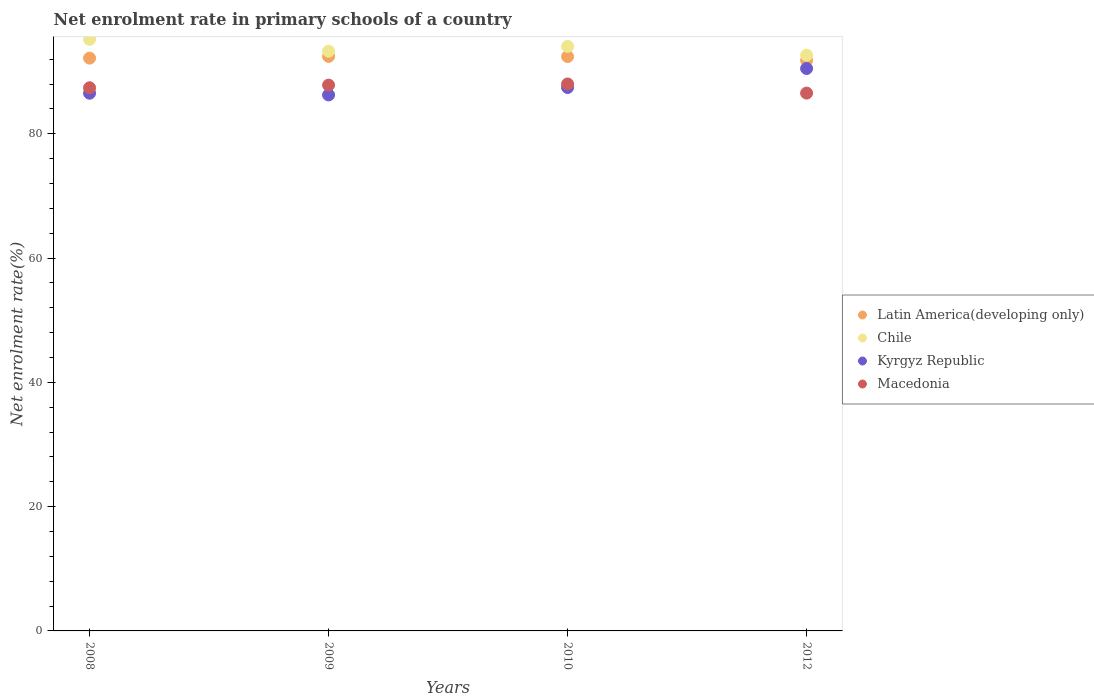How many different coloured dotlines are there?
Your answer should be compact. 4. What is the net enrolment rate in primary schools in Chile in 2010?
Your response must be concise. 94.06. Across all years, what is the maximum net enrolment rate in primary schools in Macedonia?
Your answer should be very brief. 88.02. Across all years, what is the minimum net enrolment rate in primary schools in Kyrgyz Republic?
Your answer should be compact. 86.25. In which year was the net enrolment rate in primary schools in Macedonia maximum?
Your response must be concise. 2010. What is the total net enrolment rate in primary schools in Kyrgyz Republic in the graph?
Ensure brevity in your answer.  350.74. What is the difference between the net enrolment rate in primary schools in Kyrgyz Republic in 2010 and that in 2012?
Offer a very short reply. -3.06. What is the difference between the net enrolment rate in primary schools in Chile in 2009 and the net enrolment rate in primary schools in Latin America(developing only) in 2012?
Give a very brief answer. 1.47. What is the average net enrolment rate in primary schools in Latin America(developing only) per year?
Your response must be concise. 92.22. In the year 2009, what is the difference between the net enrolment rate in primary schools in Macedonia and net enrolment rate in primary schools in Kyrgyz Republic?
Keep it short and to the point. 1.58. In how many years, is the net enrolment rate in primary schools in Kyrgyz Republic greater than 16 %?
Your answer should be compact. 4. What is the ratio of the net enrolment rate in primary schools in Macedonia in 2008 to that in 2012?
Provide a short and direct response. 1.01. Is the difference between the net enrolment rate in primary schools in Macedonia in 2009 and 2010 greater than the difference between the net enrolment rate in primary schools in Kyrgyz Republic in 2009 and 2010?
Your response must be concise. Yes. What is the difference between the highest and the second highest net enrolment rate in primary schools in Kyrgyz Republic?
Provide a succinct answer. 3.06. What is the difference between the highest and the lowest net enrolment rate in primary schools in Kyrgyz Republic?
Your answer should be compact. 4.25. Is it the case that in every year, the sum of the net enrolment rate in primary schools in Kyrgyz Republic and net enrolment rate in primary schools in Chile  is greater than the net enrolment rate in primary schools in Macedonia?
Ensure brevity in your answer.  Yes. Does the net enrolment rate in primary schools in Latin America(developing only) monotonically increase over the years?
Offer a very short reply. No. Is the net enrolment rate in primary schools in Macedonia strictly less than the net enrolment rate in primary schools in Kyrgyz Republic over the years?
Make the answer very short. No. How many dotlines are there?
Provide a succinct answer. 4. How many years are there in the graph?
Provide a short and direct response. 4. Does the graph contain any zero values?
Provide a short and direct response. No. How many legend labels are there?
Your response must be concise. 4. What is the title of the graph?
Make the answer very short. Net enrolment rate in primary schools of a country. Does "Ireland" appear as one of the legend labels in the graph?
Your response must be concise. No. What is the label or title of the X-axis?
Keep it short and to the point. Years. What is the label or title of the Y-axis?
Your answer should be very brief. Net enrolment rate(%). What is the Net enrolment rate(%) in Latin America(developing only) in 2008?
Keep it short and to the point. 92.18. What is the Net enrolment rate(%) in Chile in 2008?
Keep it short and to the point. 95.2. What is the Net enrolment rate(%) in Kyrgyz Republic in 2008?
Provide a short and direct response. 86.53. What is the Net enrolment rate(%) in Macedonia in 2008?
Provide a short and direct response. 87.41. What is the Net enrolment rate(%) in Latin America(developing only) in 2009?
Provide a succinct answer. 92.46. What is the Net enrolment rate(%) in Chile in 2009?
Offer a very short reply. 93.28. What is the Net enrolment rate(%) in Kyrgyz Republic in 2009?
Ensure brevity in your answer.  86.25. What is the Net enrolment rate(%) of Macedonia in 2009?
Your answer should be compact. 87.84. What is the Net enrolment rate(%) in Latin America(developing only) in 2010?
Offer a very short reply. 92.43. What is the Net enrolment rate(%) in Chile in 2010?
Ensure brevity in your answer.  94.06. What is the Net enrolment rate(%) of Kyrgyz Republic in 2010?
Your response must be concise. 87.45. What is the Net enrolment rate(%) in Macedonia in 2010?
Offer a very short reply. 88.02. What is the Net enrolment rate(%) of Latin America(developing only) in 2012?
Your answer should be very brief. 91.81. What is the Net enrolment rate(%) of Chile in 2012?
Your answer should be compact. 92.65. What is the Net enrolment rate(%) of Kyrgyz Republic in 2012?
Give a very brief answer. 90.51. What is the Net enrolment rate(%) of Macedonia in 2012?
Provide a short and direct response. 86.55. Across all years, what is the maximum Net enrolment rate(%) in Latin America(developing only)?
Your answer should be compact. 92.46. Across all years, what is the maximum Net enrolment rate(%) in Chile?
Give a very brief answer. 95.2. Across all years, what is the maximum Net enrolment rate(%) of Kyrgyz Republic?
Make the answer very short. 90.51. Across all years, what is the maximum Net enrolment rate(%) of Macedonia?
Your answer should be compact. 88.02. Across all years, what is the minimum Net enrolment rate(%) in Latin America(developing only)?
Provide a succinct answer. 91.81. Across all years, what is the minimum Net enrolment rate(%) in Chile?
Ensure brevity in your answer.  92.65. Across all years, what is the minimum Net enrolment rate(%) in Kyrgyz Republic?
Your answer should be very brief. 86.25. Across all years, what is the minimum Net enrolment rate(%) in Macedonia?
Make the answer very short. 86.55. What is the total Net enrolment rate(%) in Latin America(developing only) in the graph?
Provide a short and direct response. 368.88. What is the total Net enrolment rate(%) in Chile in the graph?
Make the answer very short. 375.2. What is the total Net enrolment rate(%) of Kyrgyz Republic in the graph?
Keep it short and to the point. 350.74. What is the total Net enrolment rate(%) in Macedonia in the graph?
Make the answer very short. 349.81. What is the difference between the Net enrolment rate(%) in Latin America(developing only) in 2008 and that in 2009?
Your response must be concise. -0.28. What is the difference between the Net enrolment rate(%) in Chile in 2008 and that in 2009?
Give a very brief answer. 1.92. What is the difference between the Net enrolment rate(%) of Kyrgyz Republic in 2008 and that in 2009?
Your answer should be very brief. 0.27. What is the difference between the Net enrolment rate(%) in Macedonia in 2008 and that in 2009?
Keep it short and to the point. -0.43. What is the difference between the Net enrolment rate(%) in Latin America(developing only) in 2008 and that in 2010?
Ensure brevity in your answer.  -0.25. What is the difference between the Net enrolment rate(%) of Chile in 2008 and that in 2010?
Make the answer very short. 1.14. What is the difference between the Net enrolment rate(%) in Kyrgyz Republic in 2008 and that in 2010?
Ensure brevity in your answer.  -0.92. What is the difference between the Net enrolment rate(%) in Macedonia in 2008 and that in 2010?
Give a very brief answer. -0.61. What is the difference between the Net enrolment rate(%) of Latin America(developing only) in 2008 and that in 2012?
Your response must be concise. 0.36. What is the difference between the Net enrolment rate(%) of Chile in 2008 and that in 2012?
Make the answer very short. 2.54. What is the difference between the Net enrolment rate(%) of Kyrgyz Republic in 2008 and that in 2012?
Offer a terse response. -3.98. What is the difference between the Net enrolment rate(%) of Macedonia in 2008 and that in 2012?
Ensure brevity in your answer.  0.86. What is the difference between the Net enrolment rate(%) in Latin America(developing only) in 2009 and that in 2010?
Keep it short and to the point. 0.03. What is the difference between the Net enrolment rate(%) in Chile in 2009 and that in 2010?
Ensure brevity in your answer.  -0.78. What is the difference between the Net enrolment rate(%) of Kyrgyz Republic in 2009 and that in 2010?
Provide a short and direct response. -1.19. What is the difference between the Net enrolment rate(%) in Macedonia in 2009 and that in 2010?
Ensure brevity in your answer.  -0.18. What is the difference between the Net enrolment rate(%) in Latin America(developing only) in 2009 and that in 2012?
Provide a short and direct response. 0.64. What is the difference between the Net enrolment rate(%) of Chile in 2009 and that in 2012?
Your answer should be very brief. 0.63. What is the difference between the Net enrolment rate(%) in Kyrgyz Republic in 2009 and that in 2012?
Offer a terse response. -4.25. What is the difference between the Net enrolment rate(%) of Macedonia in 2009 and that in 2012?
Offer a terse response. 1.29. What is the difference between the Net enrolment rate(%) of Latin America(developing only) in 2010 and that in 2012?
Keep it short and to the point. 0.62. What is the difference between the Net enrolment rate(%) of Chile in 2010 and that in 2012?
Make the answer very short. 1.41. What is the difference between the Net enrolment rate(%) in Kyrgyz Republic in 2010 and that in 2012?
Your response must be concise. -3.06. What is the difference between the Net enrolment rate(%) of Macedonia in 2010 and that in 2012?
Your answer should be very brief. 1.47. What is the difference between the Net enrolment rate(%) in Latin America(developing only) in 2008 and the Net enrolment rate(%) in Chile in 2009?
Your answer should be compact. -1.11. What is the difference between the Net enrolment rate(%) in Latin America(developing only) in 2008 and the Net enrolment rate(%) in Kyrgyz Republic in 2009?
Your answer should be compact. 5.92. What is the difference between the Net enrolment rate(%) of Latin America(developing only) in 2008 and the Net enrolment rate(%) of Macedonia in 2009?
Provide a succinct answer. 4.34. What is the difference between the Net enrolment rate(%) in Chile in 2008 and the Net enrolment rate(%) in Kyrgyz Republic in 2009?
Provide a succinct answer. 8.94. What is the difference between the Net enrolment rate(%) in Chile in 2008 and the Net enrolment rate(%) in Macedonia in 2009?
Make the answer very short. 7.36. What is the difference between the Net enrolment rate(%) in Kyrgyz Republic in 2008 and the Net enrolment rate(%) in Macedonia in 2009?
Keep it short and to the point. -1.31. What is the difference between the Net enrolment rate(%) in Latin America(developing only) in 2008 and the Net enrolment rate(%) in Chile in 2010?
Make the answer very short. -1.88. What is the difference between the Net enrolment rate(%) of Latin America(developing only) in 2008 and the Net enrolment rate(%) of Kyrgyz Republic in 2010?
Provide a succinct answer. 4.73. What is the difference between the Net enrolment rate(%) of Latin America(developing only) in 2008 and the Net enrolment rate(%) of Macedonia in 2010?
Offer a terse response. 4.16. What is the difference between the Net enrolment rate(%) of Chile in 2008 and the Net enrolment rate(%) of Kyrgyz Republic in 2010?
Provide a succinct answer. 7.75. What is the difference between the Net enrolment rate(%) of Chile in 2008 and the Net enrolment rate(%) of Macedonia in 2010?
Offer a terse response. 7.18. What is the difference between the Net enrolment rate(%) in Kyrgyz Republic in 2008 and the Net enrolment rate(%) in Macedonia in 2010?
Offer a very short reply. -1.49. What is the difference between the Net enrolment rate(%) in Latin America(developing only) in 2008 and the Net enrolment rate(%) in Chile in 2012?
Ensure brevity in your answer.  -0.48. What is the difference between the Net enrolment rate(%) in Latin America(developing only) in 2008 and the Net enrolment rate(%) in Kyrgyz Republic in 2012?
Offer a terse response. 1.67. What is the difference between the Net enrolment rate(%) in Latin America(developing only) in 2008 and the Net enrolment rate(%) in Macedonia in 2012?
Offer a very short reply. 5.63. What is the difference between the Net enrolment rate(%) of Chile in 2008 and the Net enrolment rate(%) of Kyrgyz Republic in 2012?
Offer a terse response. 4.69. What is the difference between the Net enrolment rate(%) in Chile in 2008 and the Net enrolment rate(%) in Macedonia in 2012?
Make the answer very short. 8.65. What is the difference between the Net enrolment rate(%) of Kyrgyz Republic in 2008 and the Net enrolment rate(%) of Macedonia in 2012?
Provide a succinct answer. -0.02. What is the difference between the Net enrolment rate(%) in Latin America(developing only) in 2009 and the Net enrolment rate(%) in Chile in 2010?
Offer a terse response. -1.61. What is the difference between the Net enrolment rate(%) in Latin America(developing only) in 2009 and the Net enrolment rate(%) in Kyrgyz Republic in 2010?
Your response must be concise. 5.01. What is the difference between the Net enrolment rate(%) in Latin America(developing only) in 2009 and the Net enrolment rate(%) in Macedonia in 2010?
Give a very brief answer. 4.44. What is the difference between the Net enrolment rate(%) in Chile in 2009 and the Net enrolment rate(%) in Kyrgyz Republic in 2010?
Your answer should be compact. 5.84. What is the difference between the Net enrolment rate(%) in Chile in 2009 and the Net enrolment rate(%) in Macedonia in 2010?
Ensure brevity in your answer.  5.26. What is the difference between the Net enrolment rate(%) of Kyrgyz Republic in 2009 and the Net enrolment rate(%) of Macedonia in 2010?
Offer a very short reply. -1.77. What is the difference between the Net enrolment rate(%) in Latin America(developing only) in 2009 and the Net enrolment rate(%) in Chile in 2012?
Offer a very short reply. -0.2. What is the difference between the Net enrolment rate(%) in Latin America(developing only) in 2009 and the Net enrolment rate(%) in Kyrgyz Republic in 2012?
Make the answer very short. 1.95. What is the difference between the Net enrolment rate(%) of Latin America(developing only) in 2009 and the Net enrolment rate(%) of Macedonia in 2012?
Your response must be concise. 5.91. What is the difference between the Net enrolment rate(%) of Chile in 2009 and the Net enrolment rate(%) of Kyrgyz Republic in 2012?
Your answer should be compact. 2.78. What is the difference between the Net enrolment rate(%) of Chile in 2009 and the Net enrolment rate(%) of Macedonia in 2012?
Offer a terse response. 6.73. What is the difference between the Net enrolment rate(%) of Kyrgyz Republic in 2009 and the Net enrolment rate(%) of Macedonia in 2012?
Ensure brevity in your answer.  -0.29. What is the difference between the Net enrolment rate(%) of Latin America(developing only) in 2010 and the Net enrolment rate(%) of Chile in 2012?
Give a very brief answer. -0.22. What is the difference between the Net enrolment rate(%) of Latin America(developing only) in 2010 and the Net enrolment rate(%) of Kyrgyz Republic in 2012?
Your answer should be very brief. 1.92. What is the difference between the Net enrolment rate(%) in Latin America(developing only) in 2010 and the Net enrolment rate(%) in Macedonia in 2012?
Keep it short and to the point. 5.88. What is the difference between the Net enrolment rate(%) in Chile in 2010 and the Net enrolment rate(%) in Kyrgyz Republic in 2012?
Your answer should be very brief. 3.56. What is the difference between the Net enrolment rate(%) in Chile in 2010 and the Net enrolment rate(%) in Macedonia in 2012?
Provide a short and direct response. 7.51. What is the difference between the Net enrolment rate(%) in Kyrgyz Republic in 2010 and the Net enrolment rate(%) in Macedonia in 2012?
Offer a terse response. 0.9. What is the average Net enrolment rate(%) of Latin America(developing only) per year?
Your response must be concise. 92.22. What is the average Net enrolment rate(%) in Chile per year?
Make the answer very short. 93.8. What is the average Net enrolment rate(%) in Kyrgyz Republic per year?
Provide a short and direct response. 87.68. What is the average Net enrolment rate(%) in Macedonia per year?
Your answer should be compact. 87.45. In the year 2008, what is the difference between the Net enrolment rate(%) in Latin America(developing only) and Net enrolment rate(%) in Chile?
Give a very brief answer. -3.02. In the year 2008, what is the difference between the Net enrolment rate(%) of Latin America(developing only) and Net enrolment rate(%) of Kyrgyz Republic?
Make the answer very short. 5.65. In the year 2008, what is the difference between the Net enrolment rate(%) in Latin America(developing only) and Net enrolment rate(%) in Macedonia?
Keep it short and to the point. 4.77. In the year 2008, what is the difference between the Net enrolment rate(%) in Chile and Net enrolment rate(%) in Kyrgyz Republic?
Offer a very short reply. 8.67. In the year 2008, what is the difference between the Net enrolment rate(%) in Chile and Net enrolment rate(%) in Macedonia?
Provide a succinct answer. 7.79. In the year 2008, what is the difference between the Net enrolment rate(%) in Kyrgyz Republic and Net enrolment rate(%) in Macedonia?
Your answer should be compact. -0.88. In the year 2009, what is the difference between the Net enrolment rate(%) of Latin America(developing only) and Net enrolment rate(%) of Chile?
Offer a terse response. -0.83. In the year 2009, what is the difference between the Net enrolment rate(%) of Latin America(developing only) and Net enrolment rate(%) of Kyrgyz Republic?
Your response must be concise. 6.2. In the year 2009, what is the difference between the Net enrolment rate(%) in Latin America(developing only) and Net enrolment rate(%) in Macedonia?
Keep it short and to the point. 4.62. In the year 2009, what is the difference between the Net enrolment rate(%) of Chile and Net enrolment rate(%) of Kyrgyz Republic?
Offer a very short reply. 7.03. In the year 2009, what is the difference between the Net enrolment rate(%) in Chile and Net enrolment rate(%) in Macedonia?
Make the answer very short. 5.45. In the year 2009, what is the difference between the Net enrolment rate(%) in Kyrgyz Republic and Net enrolment rate(%) in Macedonia?
Your answer should be compact. -1.58. In the year 2010, what is the difference between the Net enrolment rate(%) of Latin America(developing only) and Net enrolment rate(%) of Chile?
Make the answer very short. -1.63. In the year 2010, what is the difference between the Net enrolment rate(%) of Latin America(developing only) and Net enrolment rate(%) of Kyrgyz Republic?
Your answer should be very brief. 4.98. In the year 2010, what is the difference between the Net enrolment rate(%) of Latin America(developing only) and Net enrolment rate(%) of Macedonia?
Your response must be concise. 4.41. In the year 2010, what is the difference between the Net enrolment rate(%) in Chile and Net enrolment rate(%) in Kyrgyz Republic?
Your answer should be compact. 6.61. In the year 2010, what is the difference between the Net enrolment rate(%) in Chile and Net enrolment rate(%) in Macedonia?
Ensure brevity in your answer.  6.04. In the year 2010, what is the difference between the Net enrolment rate(%) of Kyrgyz Republic and Net enrolment rate(%) of Macedonia?
Provide a short and direct response. -0.57. In the year 2012, what is the difference between the Net enrolment rate(%) of Latin America(developing only) and Net enrolment rate(%) of Chile?
Offer a terse response. -0.84. In the year 2012, what is the difference between the Net enrolment rate(%) in Latin America(developing only) and Net enrolment rate(%) in Kyrgyz Republic?
Offer a very short reply. 1.31. In the year 2012, what is the difference between the Net enrolment rate(%) of Latin America(developing only) and Net enrolment rate(%) of Macedonia?
Give a very brief answer. 5.27. In the year 2012, what is the difference between the Net enrolment rate(%) in Chile and Net enrolment rate(%) in Kyrgyz Republic?
Provide a short and direct response. 2.15. In the year 2012, what is the difference between the Net enrolment rate(%) of Chile and Net enrolment rate(%) of Macedonia?
Give a very brief answer. 6.11. In the year 2012, what is the difference between the Net enrolment rate(%) in Kyrgyz Republic and Net enrolment rate(%) in Macedonia?
Provide a succinct answer. 3.96. What is the ratio of the Net enrolment rate(%) in Chile in 2008 to that in 2009?
Provide a succinct answer. 1.02. What is the ratio of the Net enrolment rate(%) of Macedonia in 2008 to that in 2009?
Give a very brief answer. 1. What is the ratio of the Net enrolment rate(%) in Chile in 2008 to that in 2010?
Your response must be concise. 1.01. What is the ratio of the Net enrolment rate(%) of Kyrgyz Republic in 2008 to that in 2010?
Your answer should be compact. 0.99. What is the ratio of the Net enrolment rate(%) in Macedonia in 2008 to that in 2010?
Your answer should be very brief. 0.99. What is the ratio of the Net enrolment rate(%) in Chile in 2008 to that in 2012?
Give a very brief answer. 1.03. What is the ratio of the Net enrolment rate(%) in Kyrgyz Republic in 2008 to that in 2012?
Make the answer very short. 0.96. What is the ratio of the Net enrolment rate(%) in Macedonia in 2008 to that in 2012?
Keep it short and to the point. 1.01. What is the ratio of the Net enrolment rate(%) in Kyrgyz Republic in 2009 to that in 2010?
Give a very brief answer. 0.99. What is the ratio of the Net enrolment rate(%) of Macedonia in 2009 to that in 2010?
Provide a short and direct response. 1. What is the ratio of the Net enrolment rate(%) in Chile in 2009 to that in 2012?
Offer a terse response. 1.01. What is the ratio of the Net enrolment rate(%) in Kyrgyz Republic in 2009 to that in 2012?
Provide a succinct answer. 0.95. What is the ratio of the Net enrolment rate(%) of Macedonia in 2009 to that in 2012?
Your answer should be very brief. 1.01. What is the ratio of the Net enrolment rate(%) of Chile in 2010 to that in 2012?
Ensure brevity in your answer.  1.02. What is the ratio of the Net enrolment rate(%) in Kyrgyz Republic in 2010 to that in 2012?
Give a very brief answer. 0.97. What is the ratio of the Net enrolment rate(%) in Macedonia in 2010 to that in 2012?
Keep it short and to the point. 1.02. What is the difference between the highest and the second highest Net enrolment rate(%) of Latin America(developing only)?
Give a very brief answer. 0.03. What is the difference between the highest and the second highest Net enrolment rate(%) of Chile?
Ensure brevity in your answer.  1.14. What is the difference between the highest and the second highest Net enrolment rate(%) in Kyrgyz Republic?
Give a very brief answer. 3.06. What is the difference between the highest and the second highest Net enrolment rate(%) in Macedonia?
Your answer should be very brief. 0.18. What is the difference between the highest and the lowest Net enrolment rate(%) in Latin America(developing only)?
Give a very brief answer. 0.64. What is the difference between the highest and the lowest Net enrolment rate(%) of Chile?
Ensure brevity in your answer.  2.54. What is the difference between the highest and the lowest Net enrolment rate(%) in Kyrgyz Republic?
Ensure brevity in your answer.  4.25. What is the difference between the highest and the lowest Net enrolment rate(%) of Macedonia?
Offer a very short reply. 1.47. 